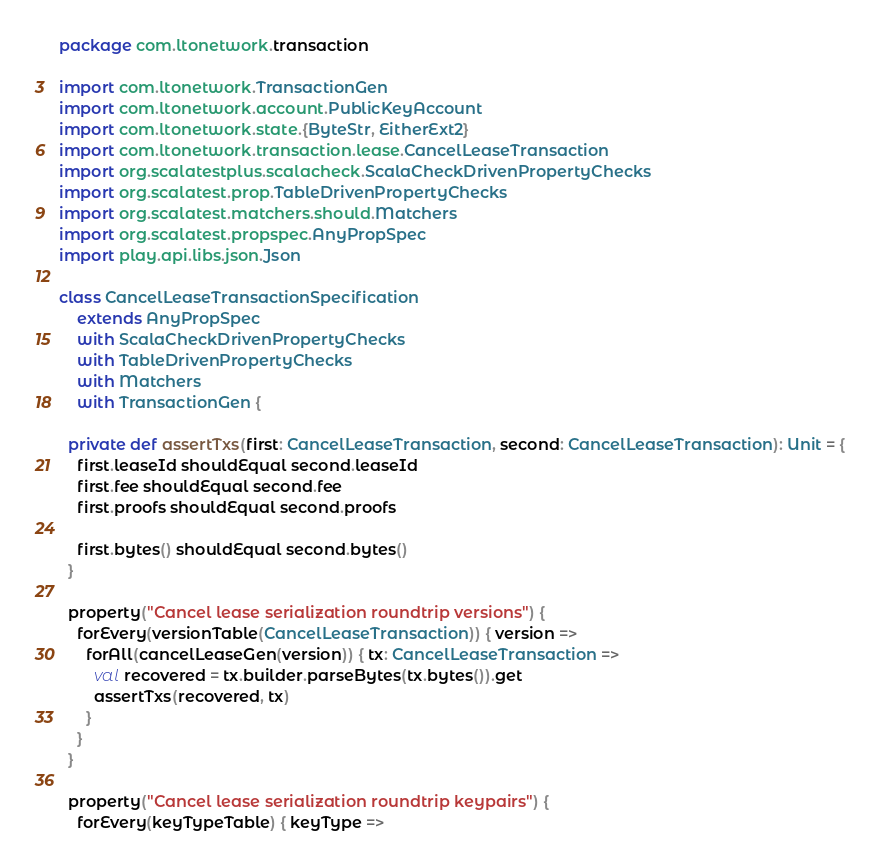<code> <loc_0><loc_0><loc_500><loc_500><_Scala_>package com.ltonetwork.transaction

import com.ltonetwork.TransactionGen
import com.ltonetwork.account.PublicKeyAccount
import com.ltonetwork.state.{ByteStr, EitherExt2}
import com.ltonetwork.transaction.lease.CancelLeaseTransaction
import org.scalatestplus.scalacheck.ScalaCheckDrivenPropertyChecks
import org.scalatest.prop.TableDrivenPropertyChecks
import org.scalatest.matchers.should.Matchers
import org.scalatest.propspec.AnyPropSpec
import play.api.libs.json.Json

class CancelLeaseTransactionSpecification
    extends AnyPropSpec
    with ScalaCheckDrivenPropertyChecks
    with TableDrivenPropertyChecks
    with Matchers
    with TransactionGen {

  private def assertTxs(first: CancelLeaseTransaction, second: CancelLeaseTransaction): Unit = {
    first.leaseId shouldEqual second.leaseId
    first.fee shouldEqual second.fee
    first.proofs shouldEqual second.proofs

    first.bytes() shouldEqual second.bytes()
  }

  property("Cancel lease serialization roundtrip versions") {
    forEvery(versionTable(CancelLeaseTransaction)) { version =>
      forAll(cancelLeaseGen(version)) { tx: CancelLeaseTransaction =>
        val recovered = tx.builder.parseBytes(tx.bytes()).get
        assertTxs(recovered, tx)
      }
    }
  }

  property("Cancel lease serialization roundtrip keypairs") {
    forEvery(keyTypeTable) { keyType =></code> 